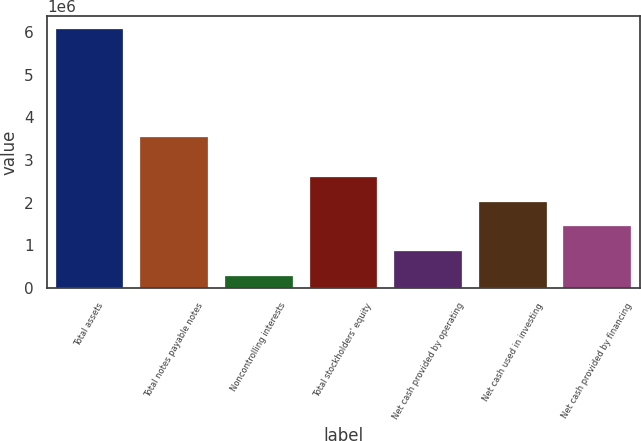<chart> <loc_0><loc_0><loc_500><loc_500><bar_chart><fcel>Total assets<fcel>Total notes payable notes<fcel>Noncontrolling interests<fcel>Total stockholders' equity<fcel>Net cash provided by operating<fcel>Net cash used in investing<fcel>Net cash provided by financing<nl><fcel>6.07141e+06<fcel>3.53562e+06<fcel>283527<fcel>2.59868e+06<fcel>862315<fcel>2.01989e+06<fcel>1.4411e+06<nl></chart> 